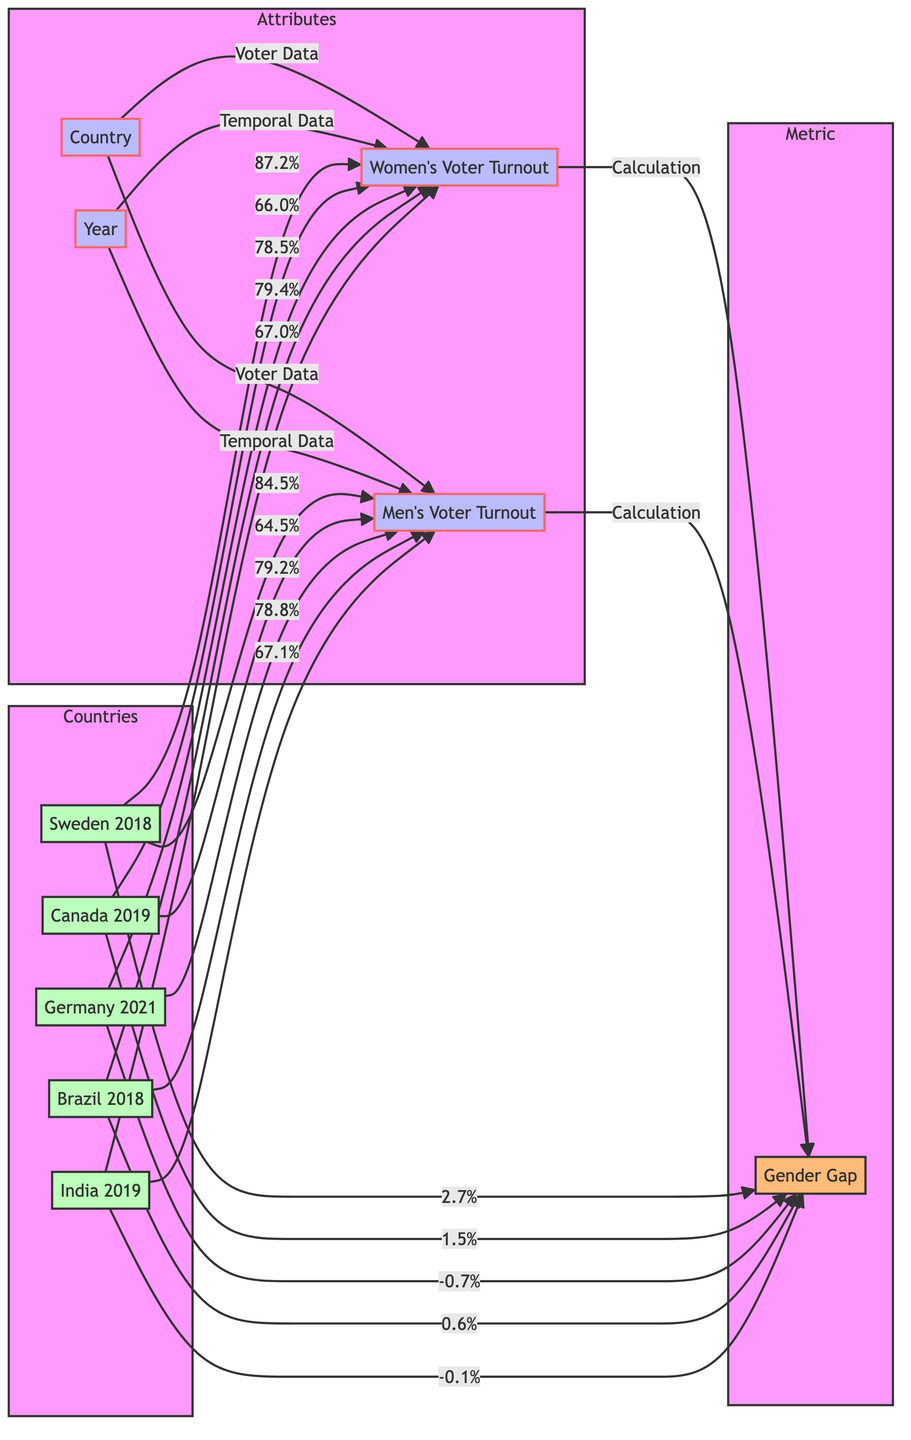What is the women's voter turnout in Sweden for 2018? According to the diagram, the women's voter turnout for Sweden in 2018 is represented by node C connected to Sweden, which shows a value of 87.2%.
Answer: 87.2% What is the gender gap in Germany for the year 2021? The gender gap in Germany for 2021 is calculated from men's voter turnout (79.2%) and women's voter turnout (78.5%), resulting in a gender gap of -0.7%.
Answer: -0.7% Which country has the highest men's voter turnout? By examining the values of men's voter turnout in the diagram, Sweden (84.5%) has the highest recorded value.
Answer: Sweden What are the women's voter turnout percentages for Canada and Brazil? The women's voter turnout percentage for Canada is 66.0%, and for Brazil, it is 79.4%. These values are found by checking the connections of these countries to node C.
Answer: Canada: 66.0%, Brazil: 79.4% Which country had a negative gender gap? The countries connected to node E show their gender gaps. The only negative value found is for Germany, with a gender gap of -0.7%.
Answer: Germany How many countries are represented in the diagram? The diagram shows five countries: Sweden, Canada, Germany, Brazil, and India. By counting the unique nodes under the Countries subgraph, the total comes out to five.
Answer: 5 Is there a country where women's voter turnout is higher than men's? Yes, in Sweden, the women's voter turnout (87.2%) is higher than the men's (84.5%). This can be determined by comparing the values of the connected nodes for both genders.
Answer: Yes What is the lowest women's voter turnout among the countries listed? The lowest women's voter turnout corresponds to India with a value of 67.0%. Checking the values for node C related to each country reveals this.
Answer: 67.0% In which year did Canada hold its national election? The diagram indicates that Canada held its election in the year 2019, which is directly connected to Canada in the year node.
Answer: 2019 